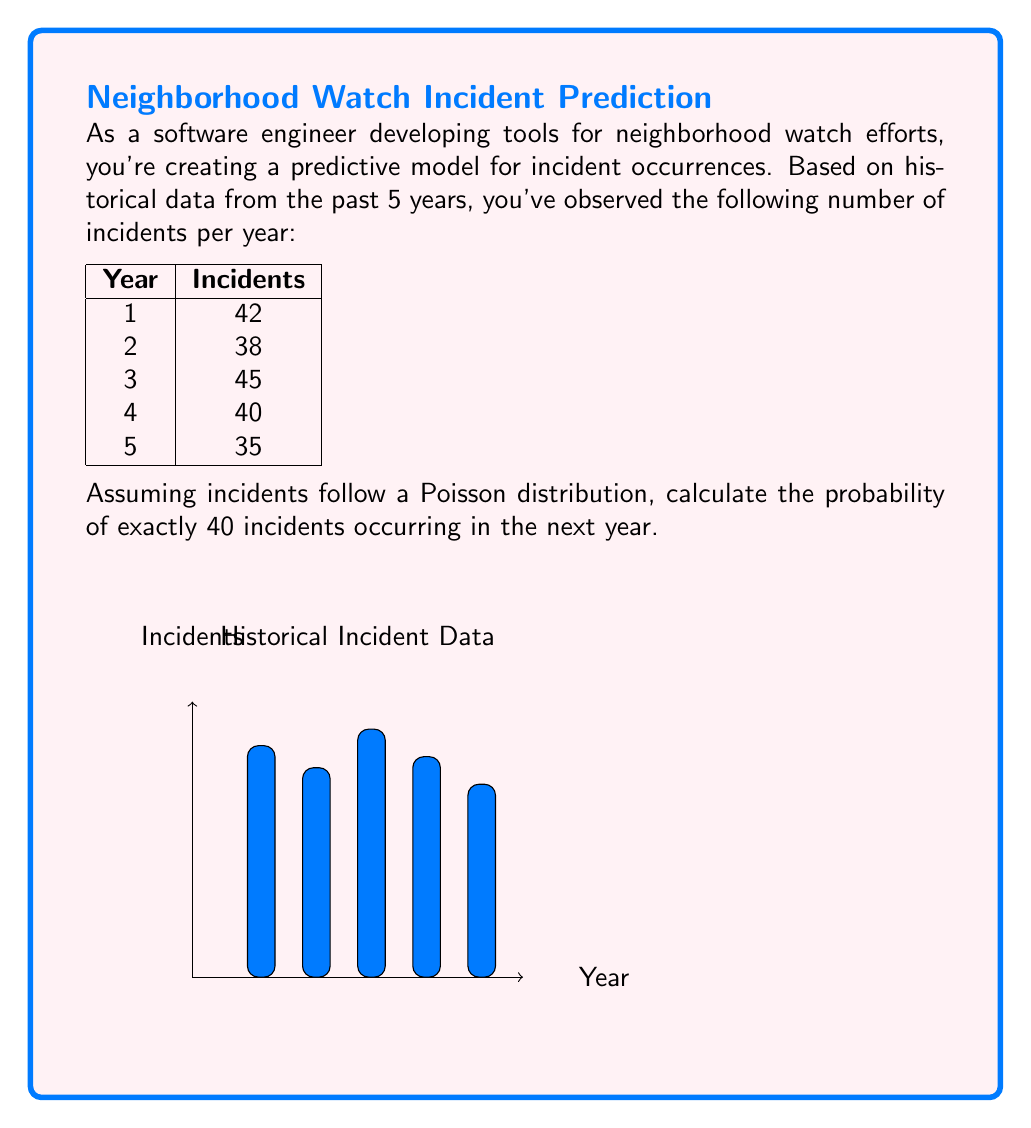What is the answer to this math problem? To solve this problem, we'll follow these steps:

1. Calculate the average number of incidents per year (λ):
   $$\lambda = \frac{42 + 38 + 45 + 40 + 35}{5} = 40$$

2. The Poisson distribution probability mass function is:
   $$P(X = k) = \frac{e^{-\lambda} \lambda^k}{k!}$$
   Where:
   - $e$ is Euler's number (approximately 2.71828)
   - $\lambda$ is the average rate of occurrence
   - $k$ is the number of occurrences we're calculating the probability for

3. Substitute the values into the formula:
   $$P(X = 40) = \frac{e^{-40} 40^{40}}{40!}$$

4. Calculate using a scientific calculator or programming language:
   $$P(X = 40) \approx 0.0631$$

This means there's approximately a 6.31% chance of exactly 40 incidents occurring in the next year, based on the historical data and assuming a Poisson distribution.
Answer: 0.0631 or 6.31% 